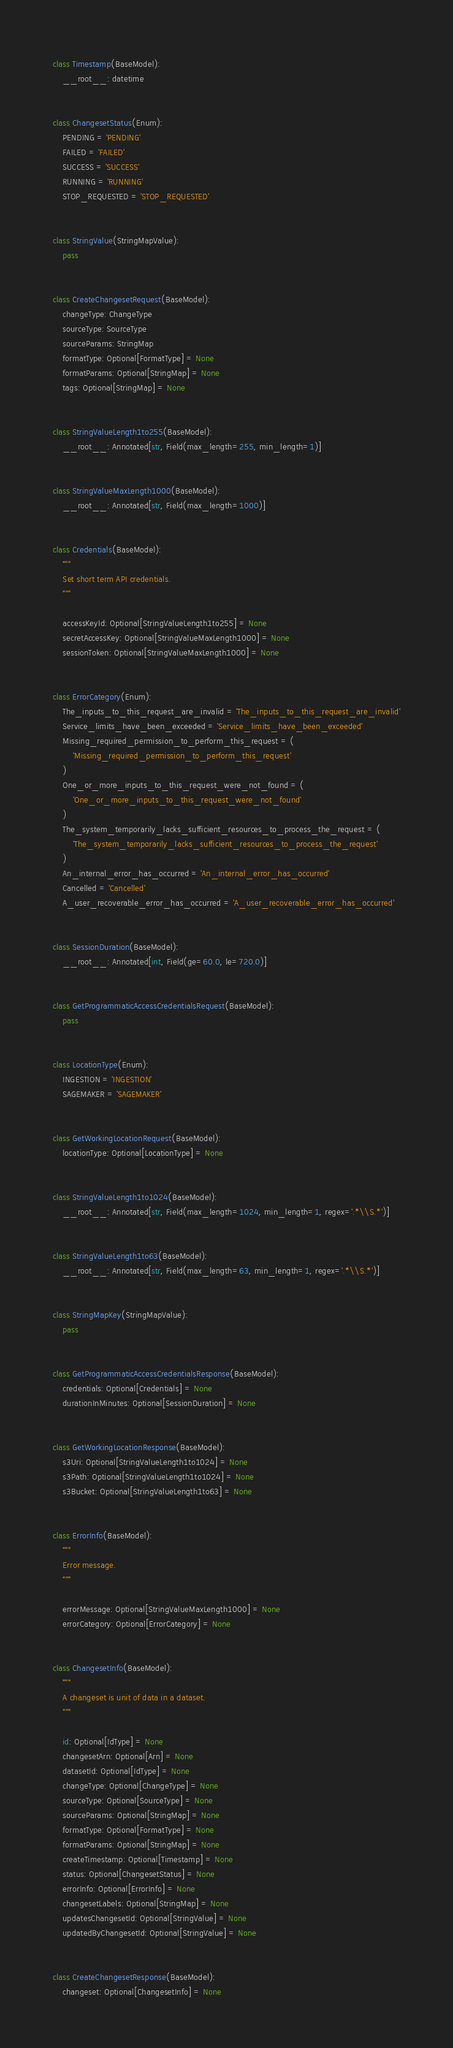<code> <loc_0><loc_0><loc_500><loc_500><_Python_>

class Timestamp(BaseModel):
    __root__: datetime


class ChangesetStatus(Enum):
    PENDING = 'PENDING'
    FAILED = 'FAILED'
    SUCCESS = 'SUCCESS'
    RUNNING = 'RUNNING'
    STOP_REQUESTED = 'STOP_REQUESTED'


class StringValue(StringMapValue):
    pass


class CreateChangesetRequest(BaseModel):
    changeType: ChangeType
    sourceType: SourceType
    sourceParams: StringMap
    formatType: Optional[FormatType] = None
    formatParams: Optional[StringMap] = None
    tags: Optional[StringMap] = None


class StringValueLength1to255(BaseModel):
    __root__: Annotated[str, Field(max_length=255, min_length=1)]


class StringValueMaxLength1000(BaseModel):
    __root__: Annotated[str, Field(max_length=1000)]


class Credentials(BaseModel):
    """
    Set short term API credentials.
    """

    accessKeyId: Optional[StringValueLength1to255] = None
    secretAccessKey: Optional[StringValueMaxLength1000] = None
    sessionToken: Optional[StringValueMaxLength1000] = None


class ErrorCategory(Enum):
    The_inputs_to_this_request_are_invalid = 'The_inputs_to_this_request_are_invalid'
    Service_limits_have_been_exceeded = 'Service_limits_have_been_exceeded'
    Missing_required_permission_to_perform_this_request = (
        'Missing_required_permission_to_perform_this_request'
    )
    One_or_more_inputs_to_this_request_were_not_found = (
        'One_or_more_inputs_to_this_request_were_not_found'
    )
    The_system_temporarily_lacks_sufficient_resources_to_process_the_request = (
        'The_system_temporarily_lacks_sufficient_resources_to_process_the_request'
    )
    An_internal_error_has_occurred = 'An_internal_error_has_occurred'
    Cancelled = 'Cancelled'
    A_user_recoverable_error_has_occurred = 'A_user_recoverable_error_has_occurred'


class SessionDuration(BaseModel):
    __root__: Annotated[int, Field(ge=60.0, le=720.0)]


class GetProgrammaticAccessCredentialsRequest(BaseModel):
    pass


class LocationType(Enum):
    INGESTION = 'INGESTION'
    SAGEMAKER = 'SAGEMAKER'


class GetWorkingLocationRequest(BaseModel):
    locationType: Optional[LocationType] = None


class StringValueLength1to1024(BaseModel):
    __root__: Annotated[str, Field(max_length=1024, min_length=1, regex='.*\\S.*')]


class StringValueLength1to63(BaseModel):
    __root__: Annotated[str, Field(max_length=63, min_length=1, regex='.*\\S.*')]


class StringMapKey(StringMapValue):
    pass


class GetProgrammaticAccessCredentialsResponse(BaseModel):
    credentials: Optional[Credentials] = None
    durationInMinutes: Optional[SessionDuration] = None


class GetWorkingLocationResponse(BaseModel):
    s3Uri: Optional[StringValueLength1to1024] = None
    s3Path: Optional[StringValueLength1to1024] = None
    s3Bucket: Optional[StringValueLength1to63] = None


class ErrorInfo(BaseModel):
    """
    Error message.
    """

    errorMessage: Optional[StringValueMaxLength1000] = None
    errorCategory: Optional[ErrorCategory] = None


class ChangesetInfo(BaseModel):
    """
    A changeset is unit of data in a dataset.
    """

    id: Optional[IdType] = None
    changesetArn: Optional[Arn] = None
    datasetId: Optional[IdType] = None
    changeType: Optional[ChangeType] = None
    sourceType: Optional[SourceType] = None
    sourceParams: Optional[StringMap] = None
    formatType: Optional[FormatType] = None
    formatParams: Optional[StringMap] = None
    createTimestamp: Optional[Timestamp] = None
    status: Optional[ChangesetStatus] = None
    errorInfo: Optional[ErrorInfo] = None
    changesetLabels: Optional[StringMap] = None
    updatesChangesetId: Optional[StringValue] = None
    updatedByChangesetId: Optional[StringValue] = None


class CreateChangesetResponse(BaseModel):
    changeset: Optional[ChangesetInfo] = None
</code> 